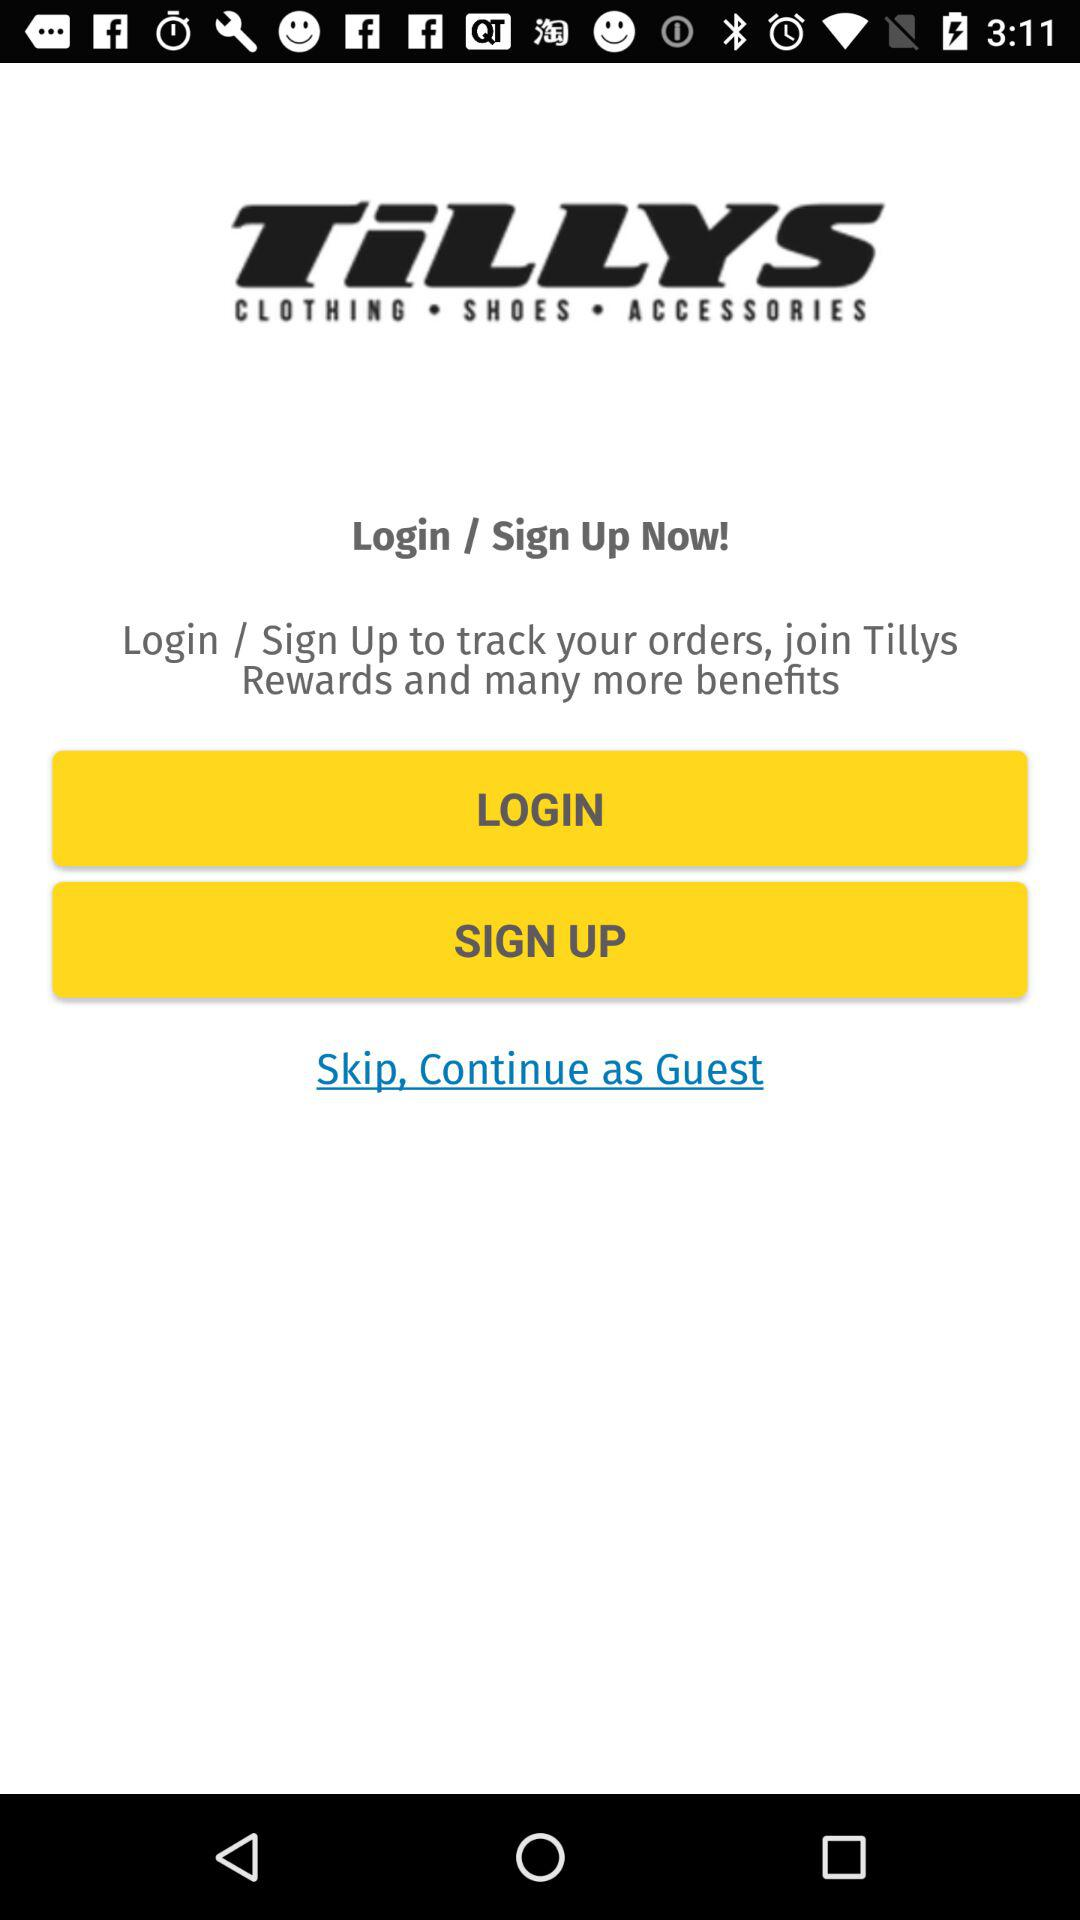What is the name of the application? The name of the application is "TiLLYS". 